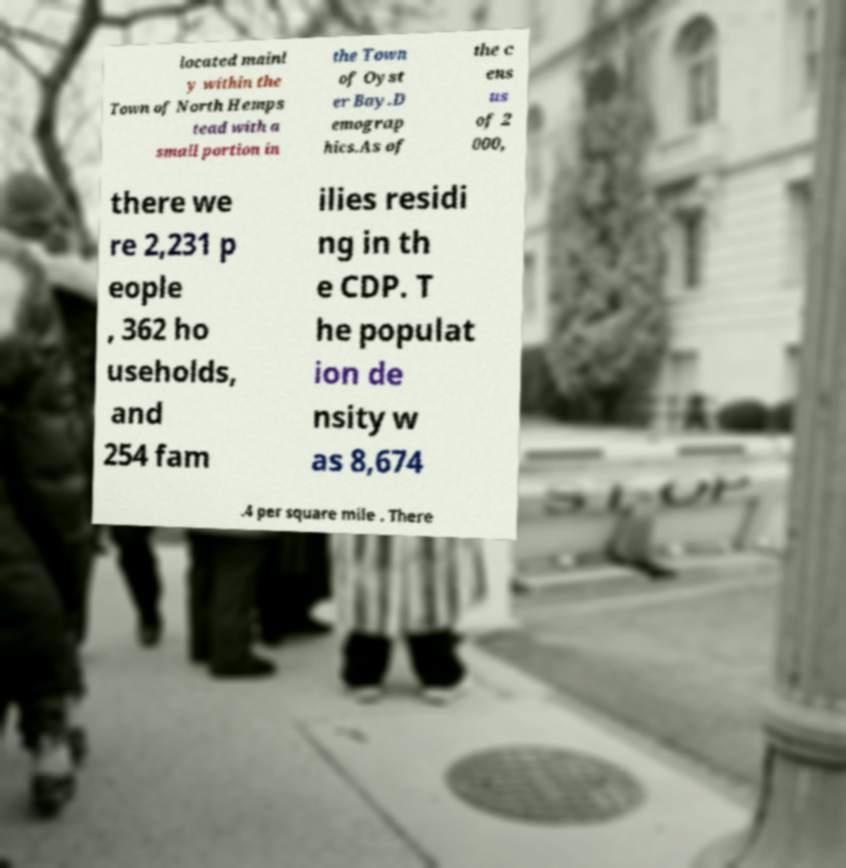There's text embedded in this image that I need extracted. Can you transcribe it verbatim? located mainl y within the Town of North Hemps tead with a small portion in the Town of Oyst er Bay.D emograp hics.As of the c ens us of 2 000, there we re 2,231 p eople , 362 ho useholds, and 254 fam ilies residi ng in th e CDP. T he populat ion de nsity w as 8,674 .4 per square mile . There 